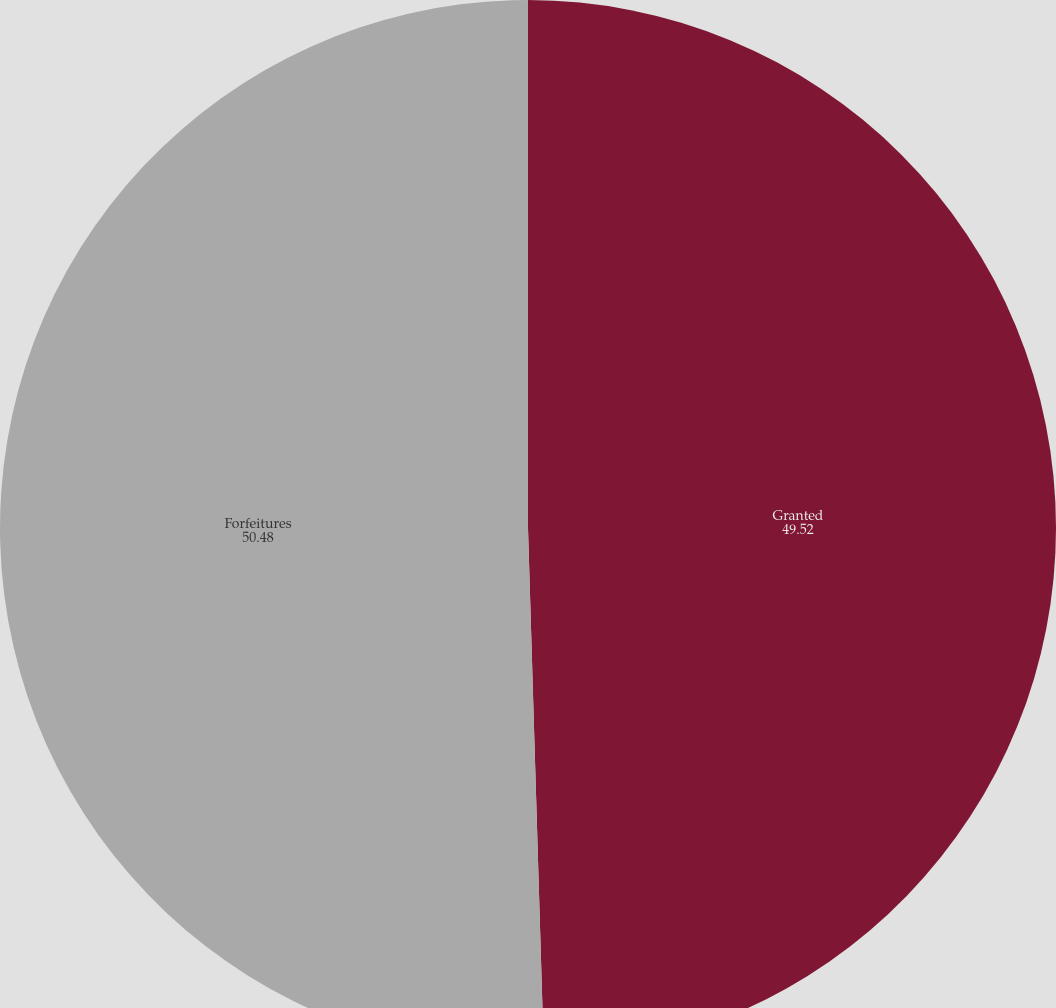Convert chart. <chart><loc_0><loc_0><loc_500><loc_500><pie_chart><fcel>Granted<fcel>Forfeitures<nl><fcel>49.52%<fcel>50.48%<nl></chart> 